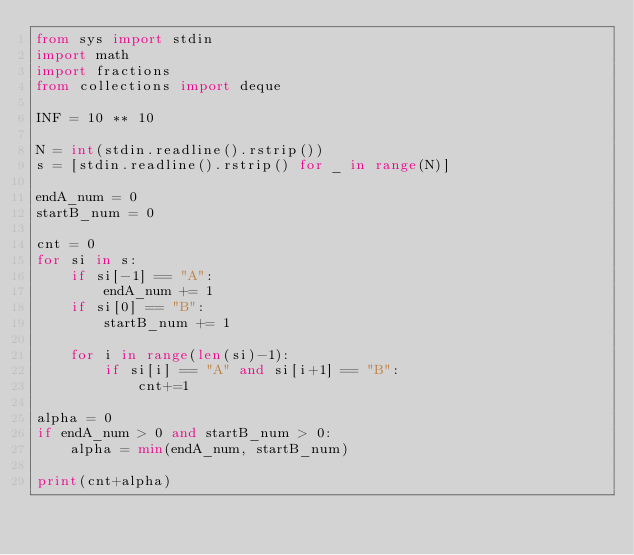<code> <loc_0><loc_0><loc_500><loc_500><_Python_>from sys import stdin
import math
import fractions
from collections import deque

INF = 10 ** 10

N = int(stdin.readline().rstrip())
s = [stdin.readline().rstrip() for _ in range(N)]

endA_num = 0
startB_num = 0

cnt = 0
for si in s:
    if si[-1] == "A":
        endA_num += 1
    if si[0] == "B":
        startB_num += 1

    for i in range(len(si)-1):
        if si[i] == "A" and si[i+1] == "B":
            cnt+=1

alpha = 0
if endA_num > 0 and startB_num > 0:
    alpha = min(endA_num, startB_num)

print(cnt+alpha)

</code> 